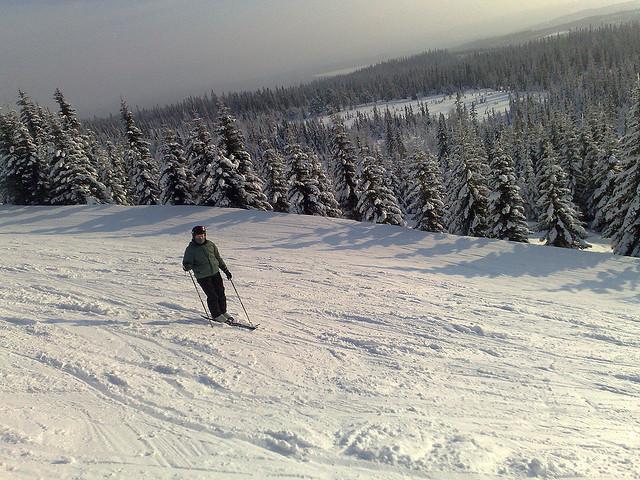Is this person moving fast across the snow?
Quick response, please. No. What color is his jacket?
Write a very short answer. Gray. What are those land formations in the background?
Give a very brief answer. Mountains. Is this person Skiing or Snowboarding?
Keep it brief. Skiing. How many trees are in the background?
Give a very brief answer. Lots. What color is the man's jacket?
Keep it brief. Gray. Is there snow?
Short answer required. Yes. Are there clouds in the background?
Write a very short answer. Yes. 